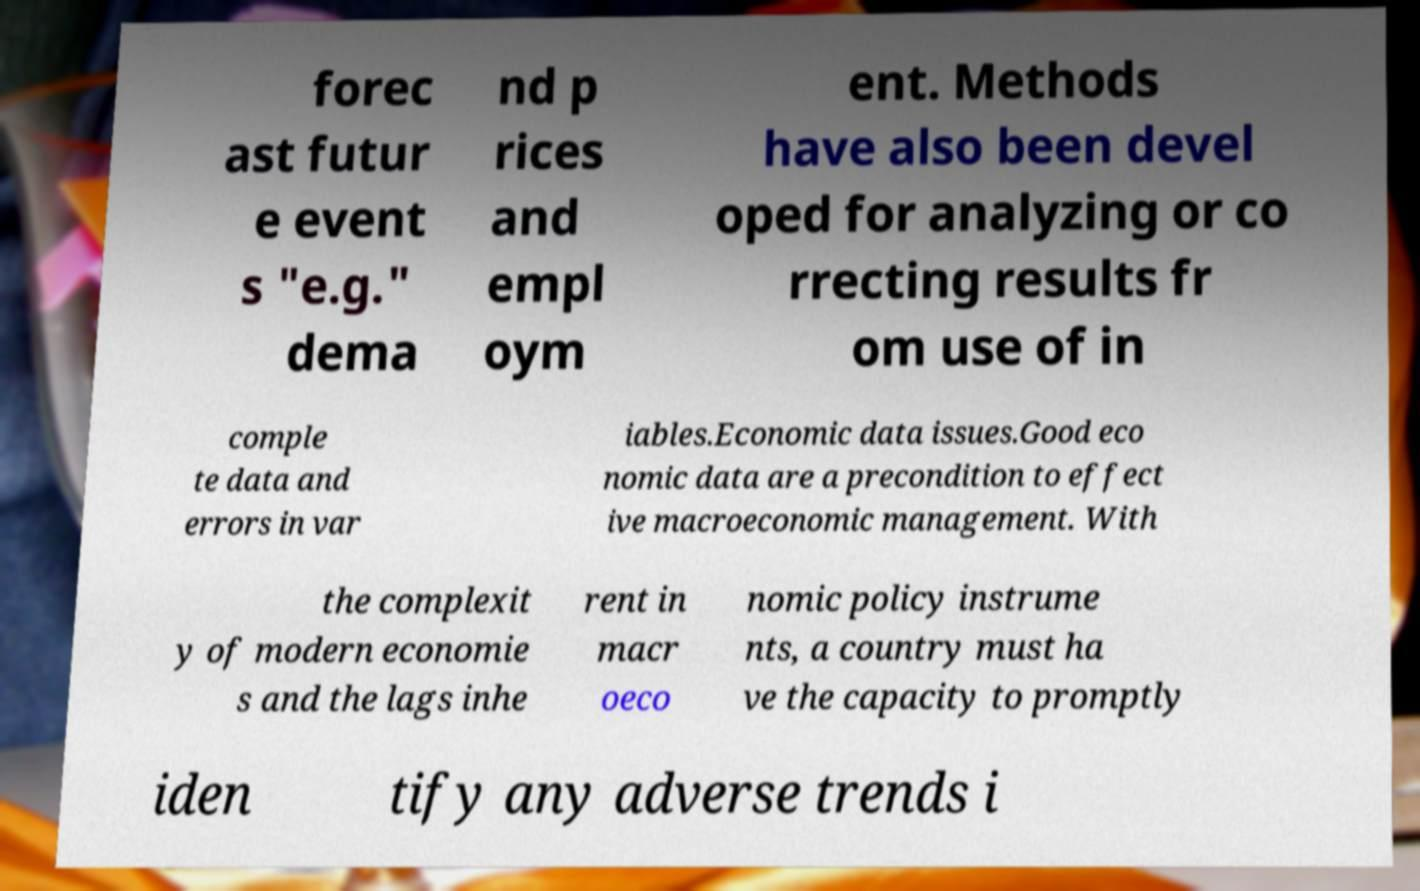There's text embedded in this image that I need extracted. Can you transcribe it verbatim? forec ast futur e event s "e.g." dema nd p rices and empl oym ent. Methods have also been devel oped for analyzing or co rrecting results fr om use of in comple te data and errors in var iables.Economic data issues.Good eco nomic data are a precondition to effect ive macroeconomic management. With the complexit y of modern economie s and the lags inhe rent in macr oeco nomic policy instrume nts, a country must ha ve the capacity to promptly iden tify any adverse trends i 